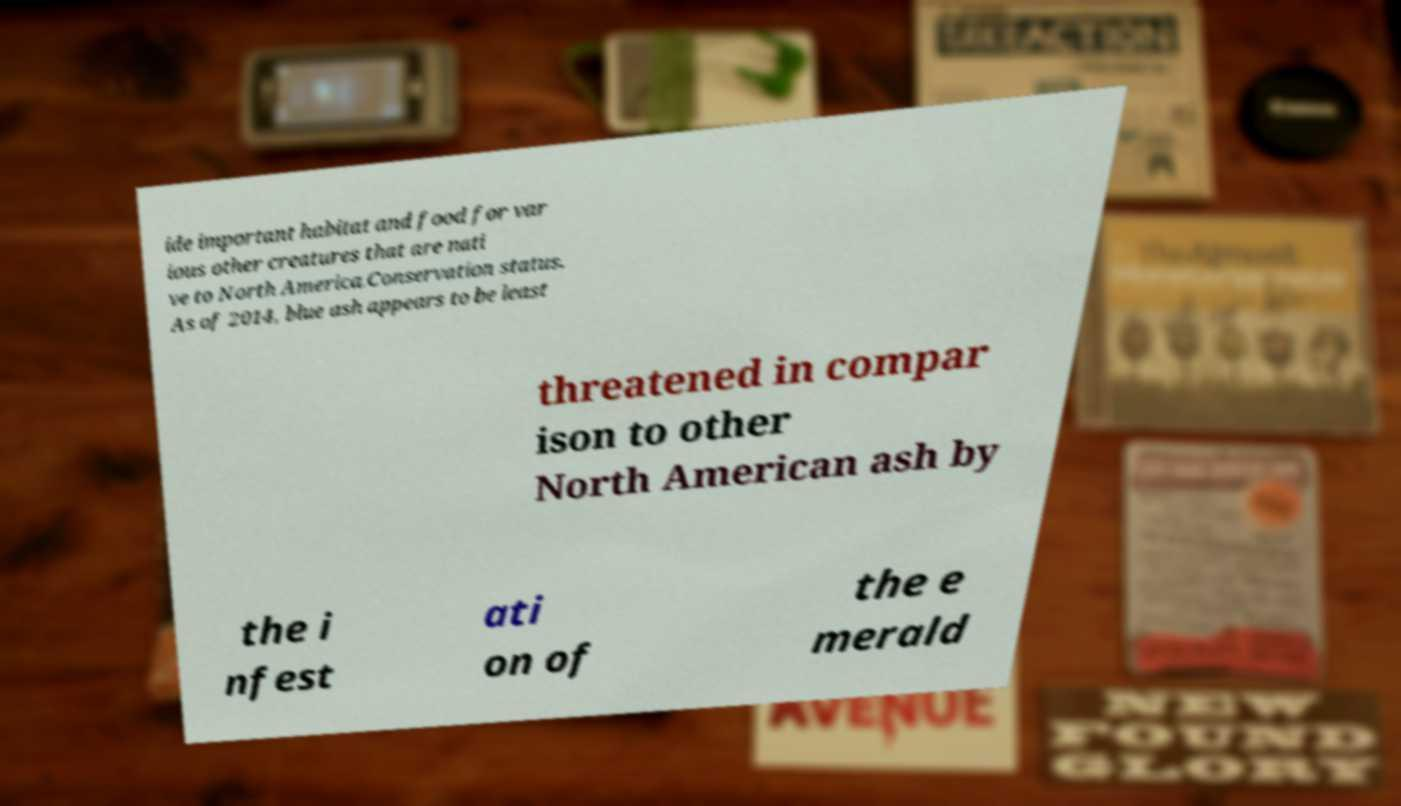There's text embedded in this image that I need extracted. Can you transcribe it verbatim? ide important habitat and food for var ious other creatures that are nati ve to North America.Conservation status. As of 2014, blue ash appears to be least threatened in compar ison to other North American ash by the i nfest ati on of the e merald 